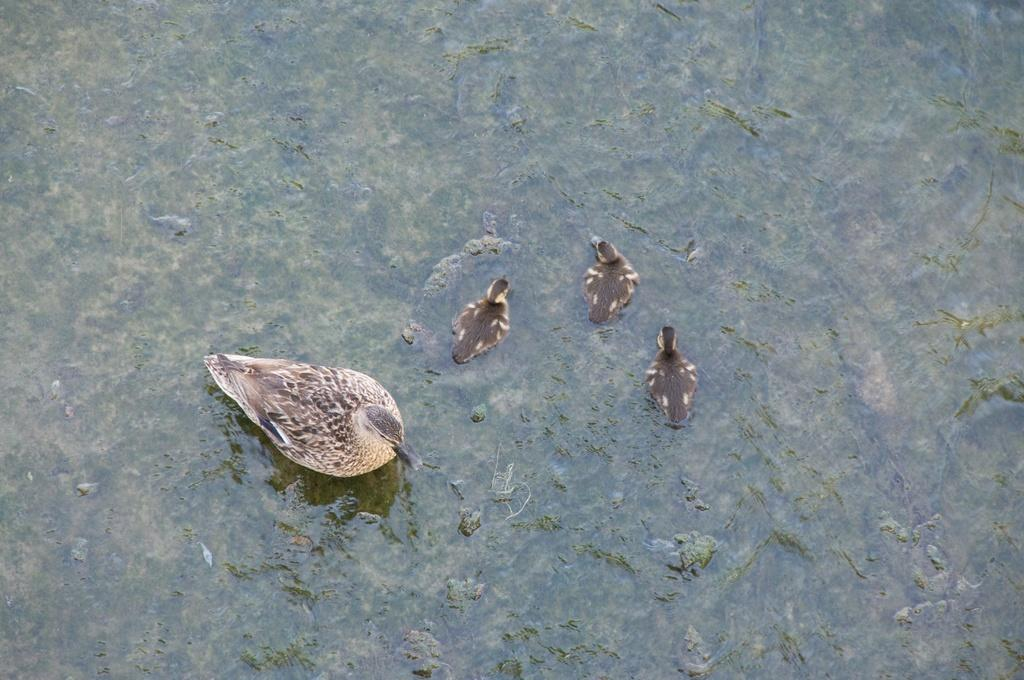What type of animals can be seen in the image? Birds can be seen in the image. Where are the birds situated? The birds are situated in water. What type of worm can be seen crawling out of the faucet in the image? There is no faucet or worm present in the image; it features birds in the water. 